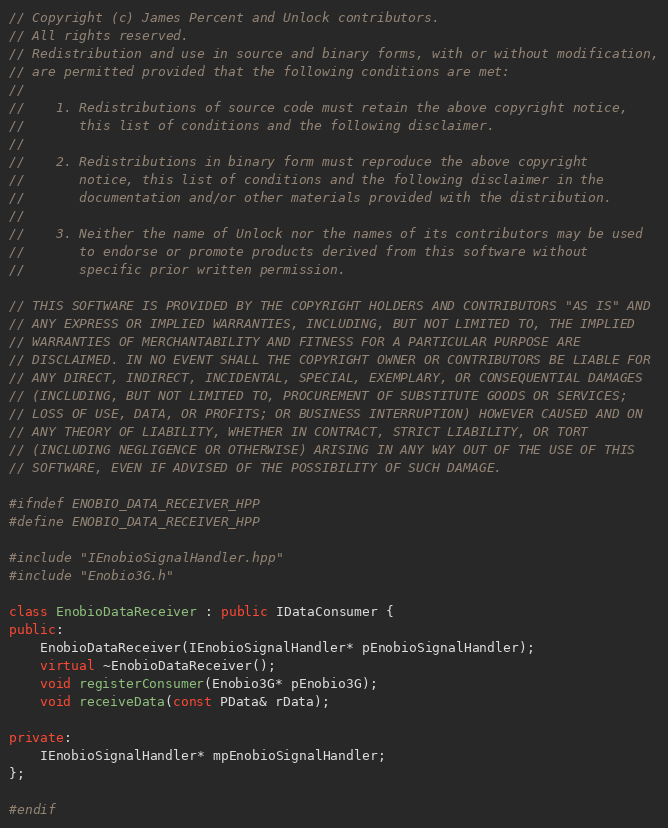<code> <loc_0><loc_0><loc_500><loc_500><_C++_>
// Copyright (c) James Percent and Unlock contributors.
// All rights reserved.
// Redistribution and use in source and binary forms, with or without modification,
// are permitted provided that the following conditions are met:
//
//    1. Redistributions of source code must retain the above copyright notice,
//       this list of conditions and the following disclaimer.
//    
//    2. Redistributions in binary form must reproduce the above copyright
//       notice, this list of conditions and the following disclaimer in the
//       documentation and/or other materials provided with the distribution.
//
//    3. Neither the name of Unlock nor the names of its contributors may be used
//       to endorse or promote products derived from this software without
//       specific prior written permission.

// THIS SOFTWARE IS PROVIDED BY THE COPYRIGHT HOLDERS AND CONTRIBUTORS "AS IS" AND
// ANY EXPRESS OR IMPLIED WARRANTIES, INCLUDING, BUT NOT LIMITED TO, THE IMPLIED
// WARRANTIES OF MERCHANTABILITY AND FITNESS FOR A PARTICULAR PURPOSE ARE
// DISCLAIMED. IN NO EVENT SHALL THE COPYRIGHT OWNER OR CONTRIBUTORS BE LIABLE FOR
// ANY DIRECT, INDIRECT, INCIDENTAL, SPECIAL, EXEMPLARY, OR CONSEQUENTIAL DAMAGES
// (INCLUDING, BUT NOT LIMITED TO, PROCUREMENT OF SUBSTITUTE GOODS OR SERVICES;
// LOSS OF USE, DATA, OR PROFITS; OR BUSINESS INTERRUPTION) HOWEVER CAUSED AND ON
// ANY THEORY OF LIABILITY, WHETHER IN CONTRACT, STRICT LIABILITY, OR TORT
// (INCLUDING NEGLIGENCE OR OTHERWISE) ARISING IN ANY WAY OUT OF THE USE OF THIS
// SOFTWARE, EVEN IF ADVISED OF THE POSSIBILITY OF SUCH DAMAGE.

#ifndef ENOBIO_DATA_RECEIVER_HPP
#define ENOBIO_DATA_RECEIVER_HPP

#include "IEnobioSignalHandler.hpp"
#include "Enobio3G.h"

class EnobioDataReceiver : public IDataConsumer {
public:
    EnobioDataReceiver(IEnobioSignalHandler* pEnobioSignalHandler);
    virtual ~EnobioDataReceiver();
    void registerConsumer(Enobio3G* pEnobio3G);
    void receiveData(const PData& rData);
    
private:
    IEnobioSignalHandler* mpEnobioSignalHandler;
};

#endif</code> 